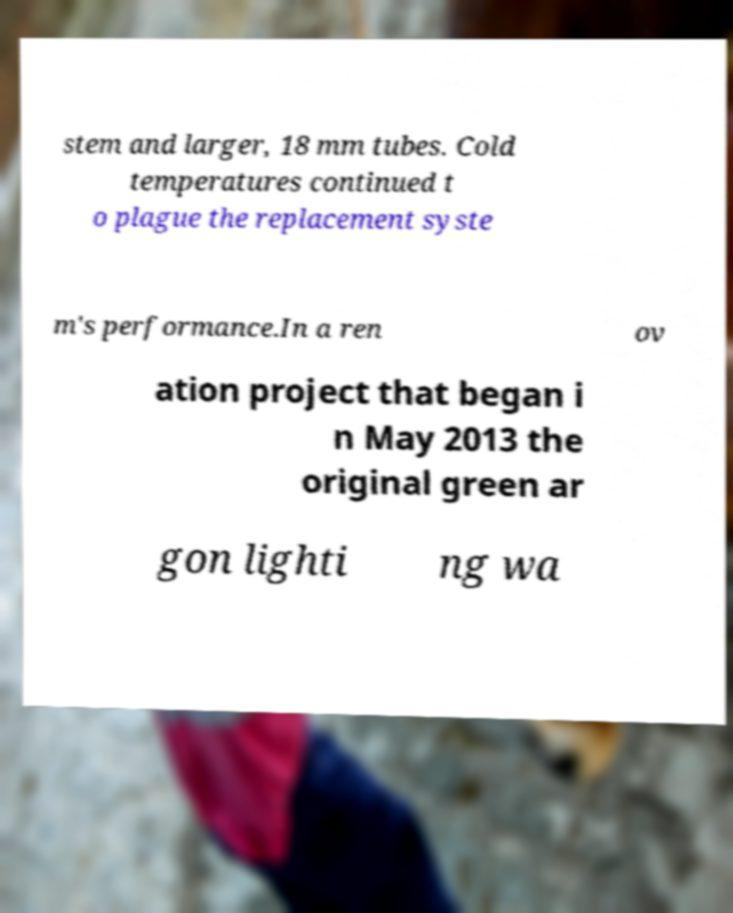Can you read and provide the text displayed in the image?This photo seems to have some interesting text. Can you extract and type it out for me? stem and larger, 18 mm tubes. Cold temperatures continued t o plague the replacement syste m's performance.In a ren ov ation project that began i n May 2013 the original green ar gon lighti ng wa 